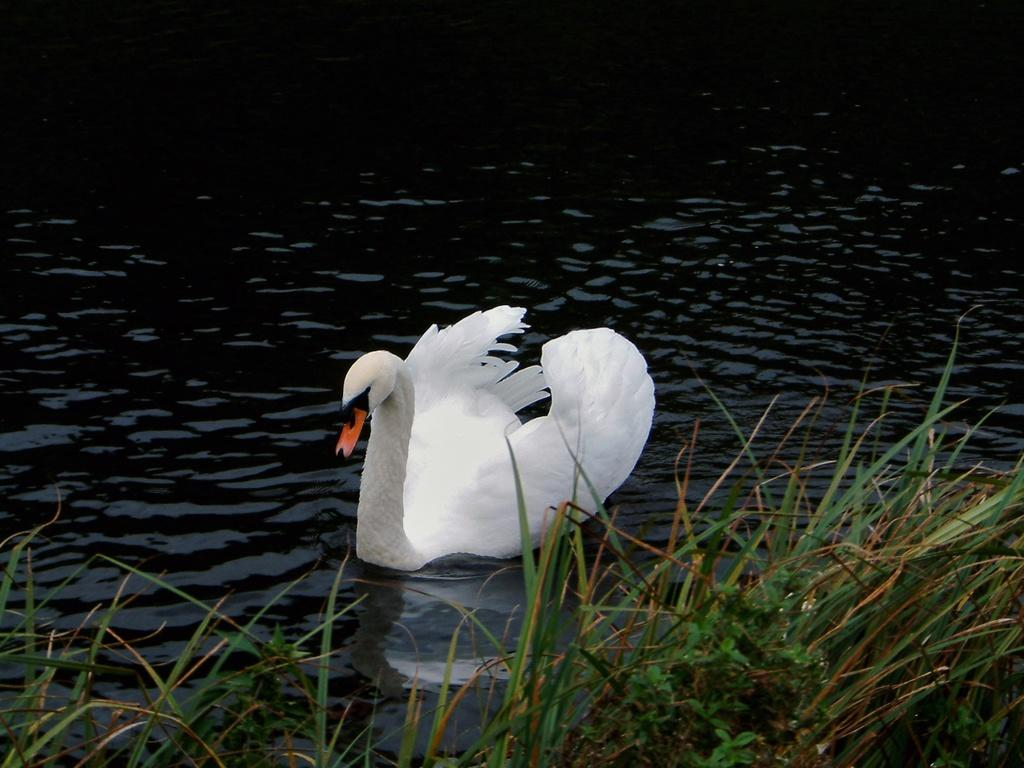What type of vegetation is visible in the foreground of the image? There is grass in the foreground of the image. What can be seen in the background of the image? There is water in the background of the image. What type of animal is present on the water? There is a swan on the water. What is the farmer saying good-bye to in the image? There is no farmer present in the image, so it is not possible to determine what they might be saying good-bye to. What is the swan's self-reflection in the image? There is no mention of a mirror or reflection in the image, so it is not possible to determine the swan's self-reflection. 